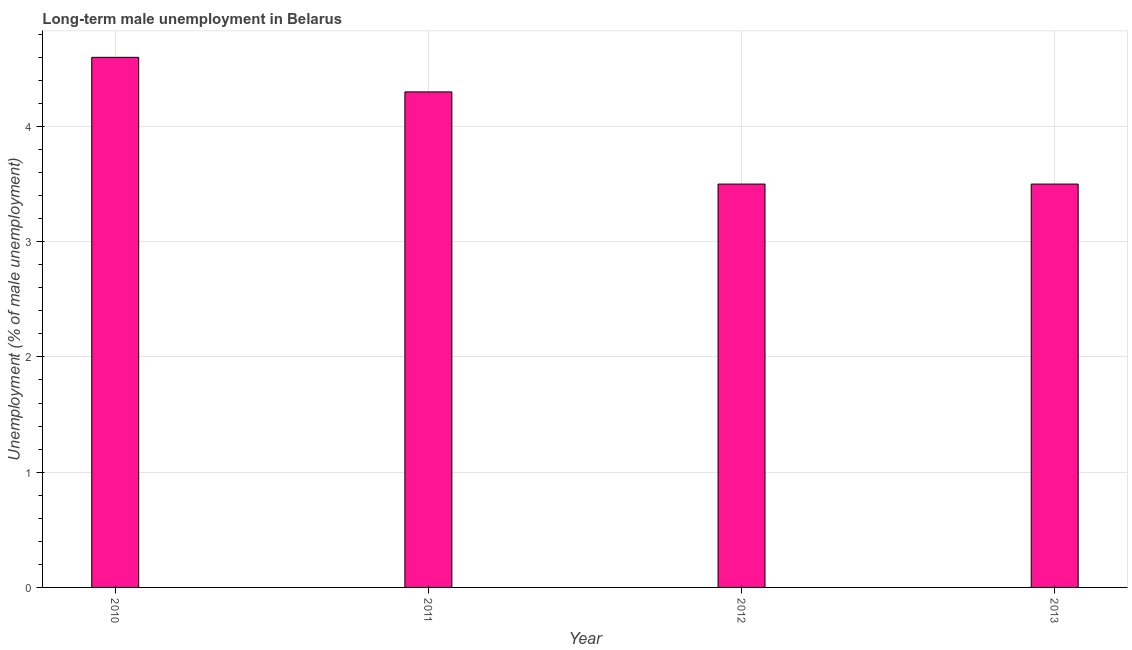Does the graph contain any zero values?
Offer a very short reply. No. Does the graph contain grids?
Provide a short and direct response. Yes. What is the title of the graph?
Your answer should be very brief. Long-term male unemployment in Belarus. What is the label or title of the Y-axis?
Give a very brief answer. Unemployment (% of male unemployment). What is the long-term male unemployment in 2011?
Provide a short and direct response. 4.3. Across all years, what is the maximum long-term male unemployment?
Provide a short and direct response. 4.6. Across all years, what is the minimum long-term male unemployment?
Give a very brief answer. 3.5. What is the sum of the long-term male unemployment?
Ensure brevity in your answer.  15.9. What is the average long-term male unemployment per year?
Make the answer very short. 3.98. What is the median long-term male unemployment?
Your answer should be compact. 3.9. What is the ratio of the long-term male unemployment in 2010 to that in 2012?
Offer a very short reply. 1.31. Is the long-term male unemployment in 2011 less than that in 2012?
Offer a very short reply. No. What is the difference between the highest and the second highest long-term male unemployment?
Give a very brief answer. 0.3. What is the difference between the highest and the lowest long-term male unemployment?
Make the answer very short. 1.1. In how many years, is the long-term male unemployment greater than the average long-term male unemployment taken over all years?
Your answer should be very brief. 2. How many years are there in the graph?
Give a very brief answer. 4. Are the values on the major ticks of Y-axis written in scientific E-notation?
Your answer should be compact. No. What is the Unemployment (% of male unemployment) in 2010?
Your answer should be very brief. 4.6. What is the Unemployment (% of male unemployment) of 2011?
Ensure brevity in your answer.  4.3. What is the difference between the Unemployment (% of male unemployment) in 2010 and 2012?
Provide a short and direct response. 1.1. What is the difference between the Unemployment (% of male unemployment) in 2010 and 2013?
Offer a very short reply. 1.1. What is the difference between the Unemployment (% of male unemployment) in 2011 and 2012?
Your answer should be compact. 0.8. What is the difference between the Unemployment (% of male unemployment) in 2011 and 2013?
Provide a short and direct response. 0.8. What is the ratio of the Unemployment (% of male unemployment) in 2010 to that in 2011?
Your answer should be very brief. 1.07. What is the ratio of the Unemployment (% of male unemployment) in 2010 to that in 2012?
Provide a succinct answer. 1.31. What is the ratio of the Unemployment (% of male unemployment) in 2010 to that in 2013?
Offer a terse response. 1.31. What is the ratio of the Unemployment (% of male unemployment) in 2011 to that in 2012?
Provide a succinct answer. 1.23. What is the ratio of the Unemployment (% of male unemployment) in 2011 to that in 2013?
Give a very brief answer. 1.23. What is the ratio of the Unemployment (% of male unemployment) in 2012 to that in 2013?
Make the answer very short. 1. 